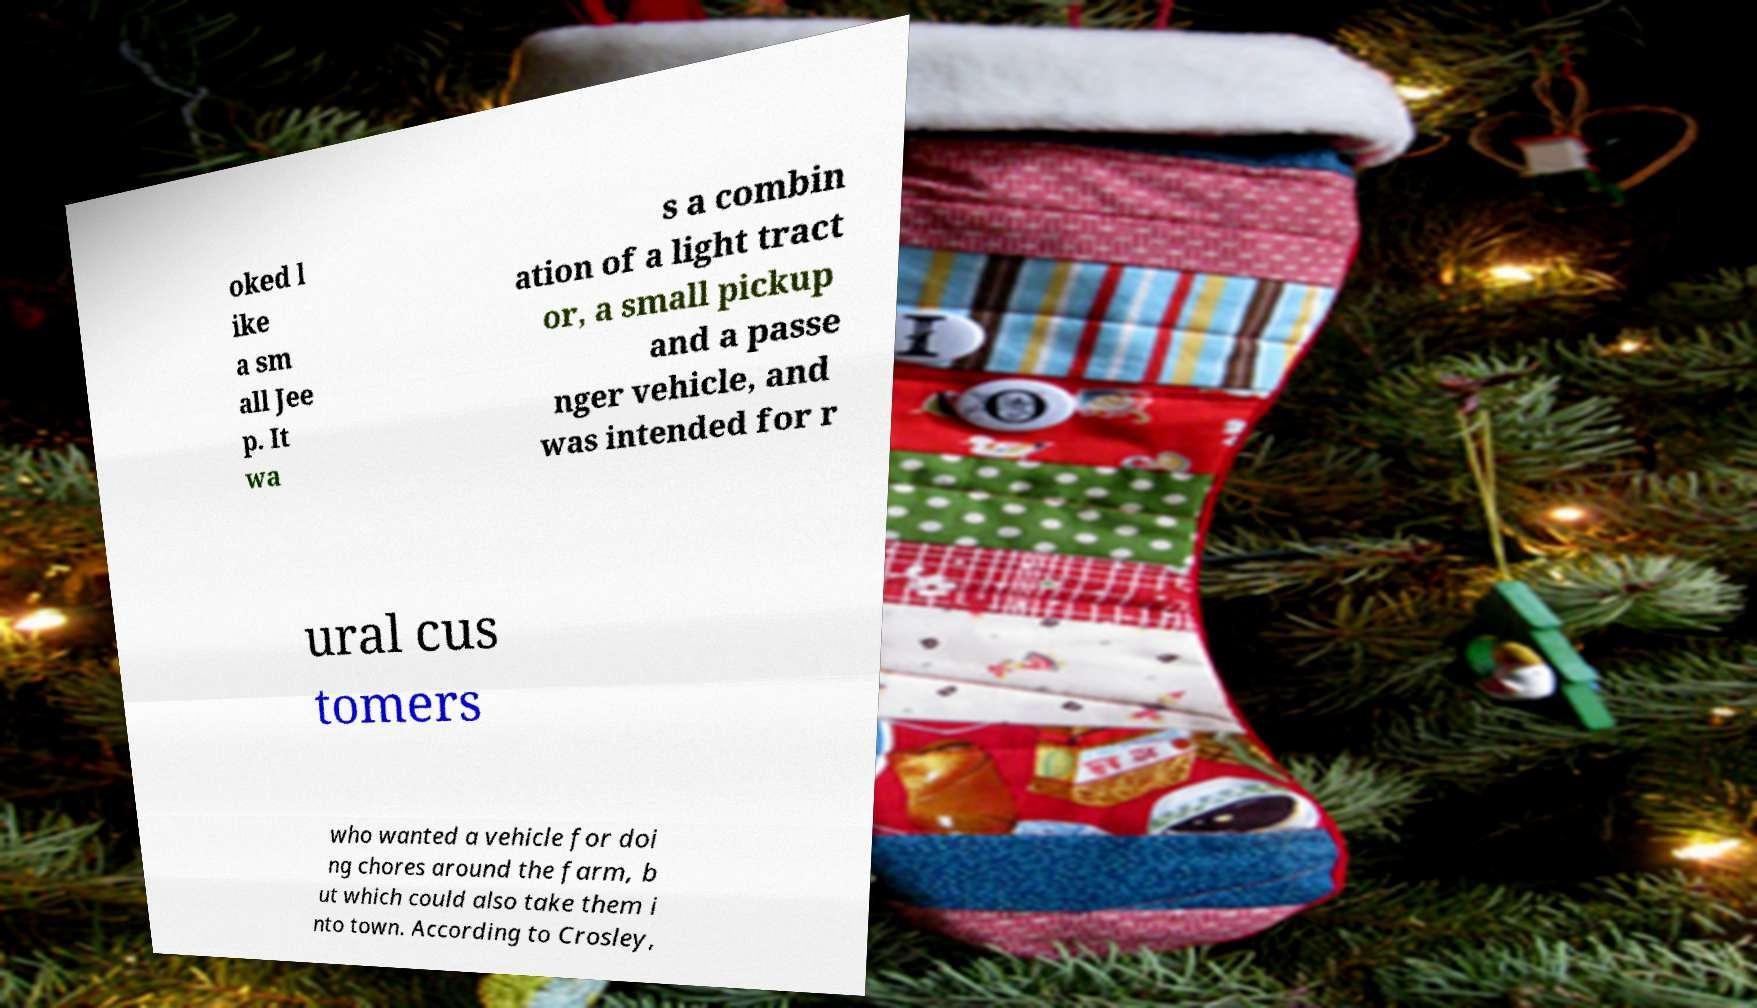Could you assist in decoding the text presented in this image and type it out clearly? oked l ike a sm all Jee p. It wa s a combin ation of a light tract or, a small pickup and a passe nger vehicle, and was intended for r ural cus tomers who wanted a vehicle for doi ng chores around the farm, b ut which could also take them i nto town. According to Crosley, 